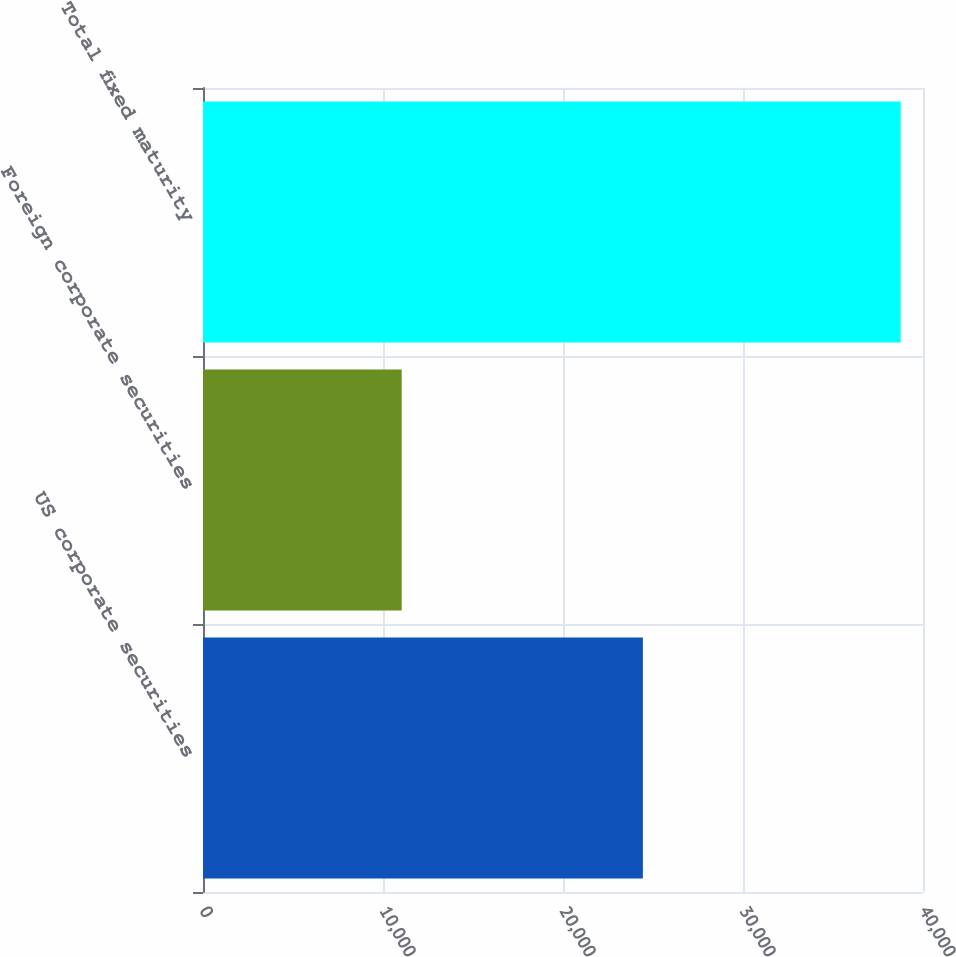Convert chart. <chart><loc_0><loc_0><loc_500><loc_500><bar_chart><fcel>US corporate securities<fcel>Foreign corporate securities<fcel>Total fixed maturity<nl><fcel>24438<fcel>11039<fcel>38761<nl></chart> 